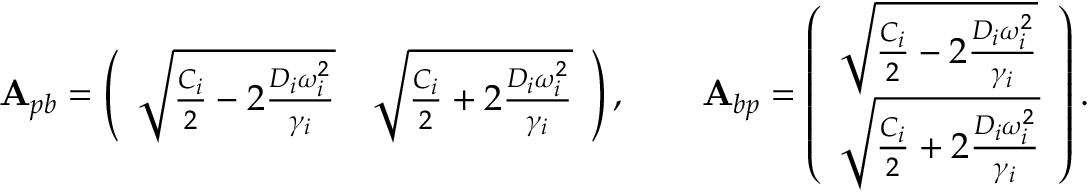<formula> <loc_0><loc_0><loc_500><loc_500>A _ { p b } = \left ( \begin{array} { l l } { \sqrt { \frac { C _ { i } } { 2 } - 2 \frac { D _ { i } \omega _ { i } ^ { 2 } } { \gamma _ { i } } } } & { \sqrt { \frac { C _ { i } } { 2 } + 2 \frac { D _ { i } \omega _ { i } ^ { 2 } } { \gamma _ { i } } } } \end{array} \right ) , \quad A _ { b p } = \left ( \begin{array} { l } { \sqrt { \frac { C _ { i } } { 2 } - 2 \frac { D _ { i } \omega _ { i } ^ { 2 } } { \gamma _ { i } } } } \\ { \sqrt { \frac { C _ { i } } { 2 } + 2 \frac { D _ { i } \omega _ { i } ^ { 2 } } { \gamma _ { i } } } } \end{array} \right ) .</formula> 